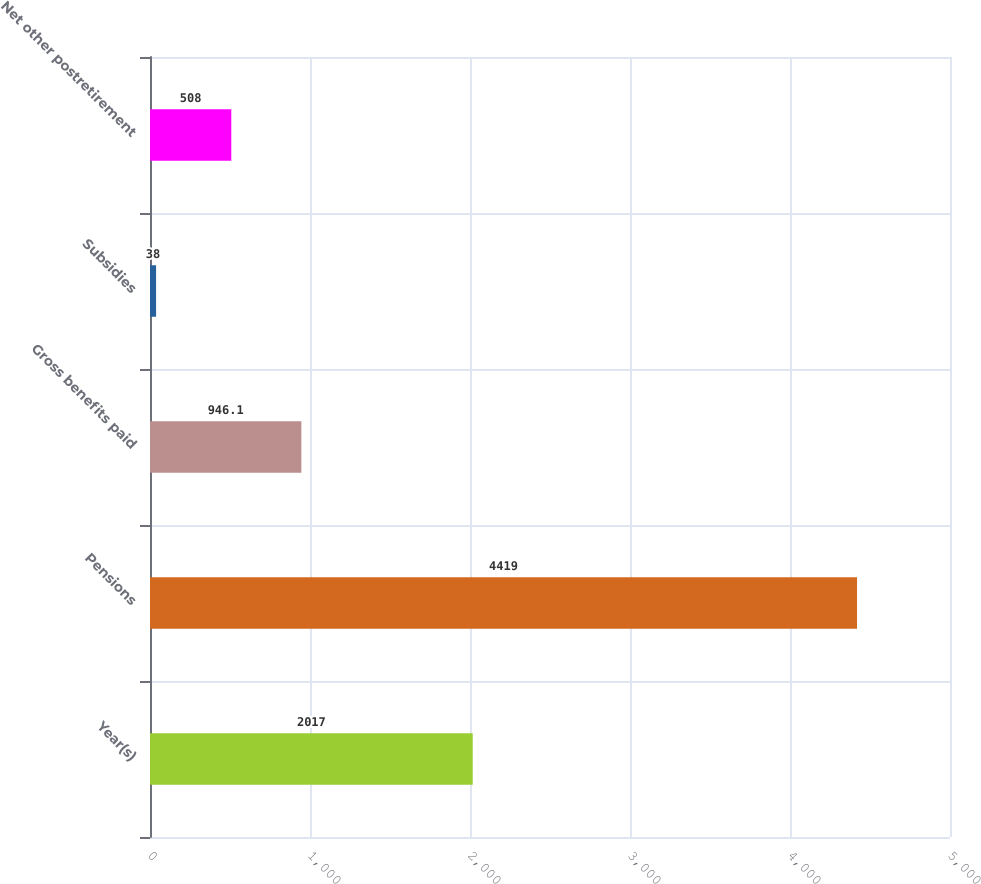Convert chart. <chart><loc_0><loc_0><loc_500><loc_500><bar_chart><fcel>Year(s)<fcel>Pensions<fcel>Gross benefits paid<fcel>Subsidies<fcel>Net other postretirement<nl><fcel>2017<fcel>4419<fcel>946.1<fcel>38<fcel>508<nl></chart> 